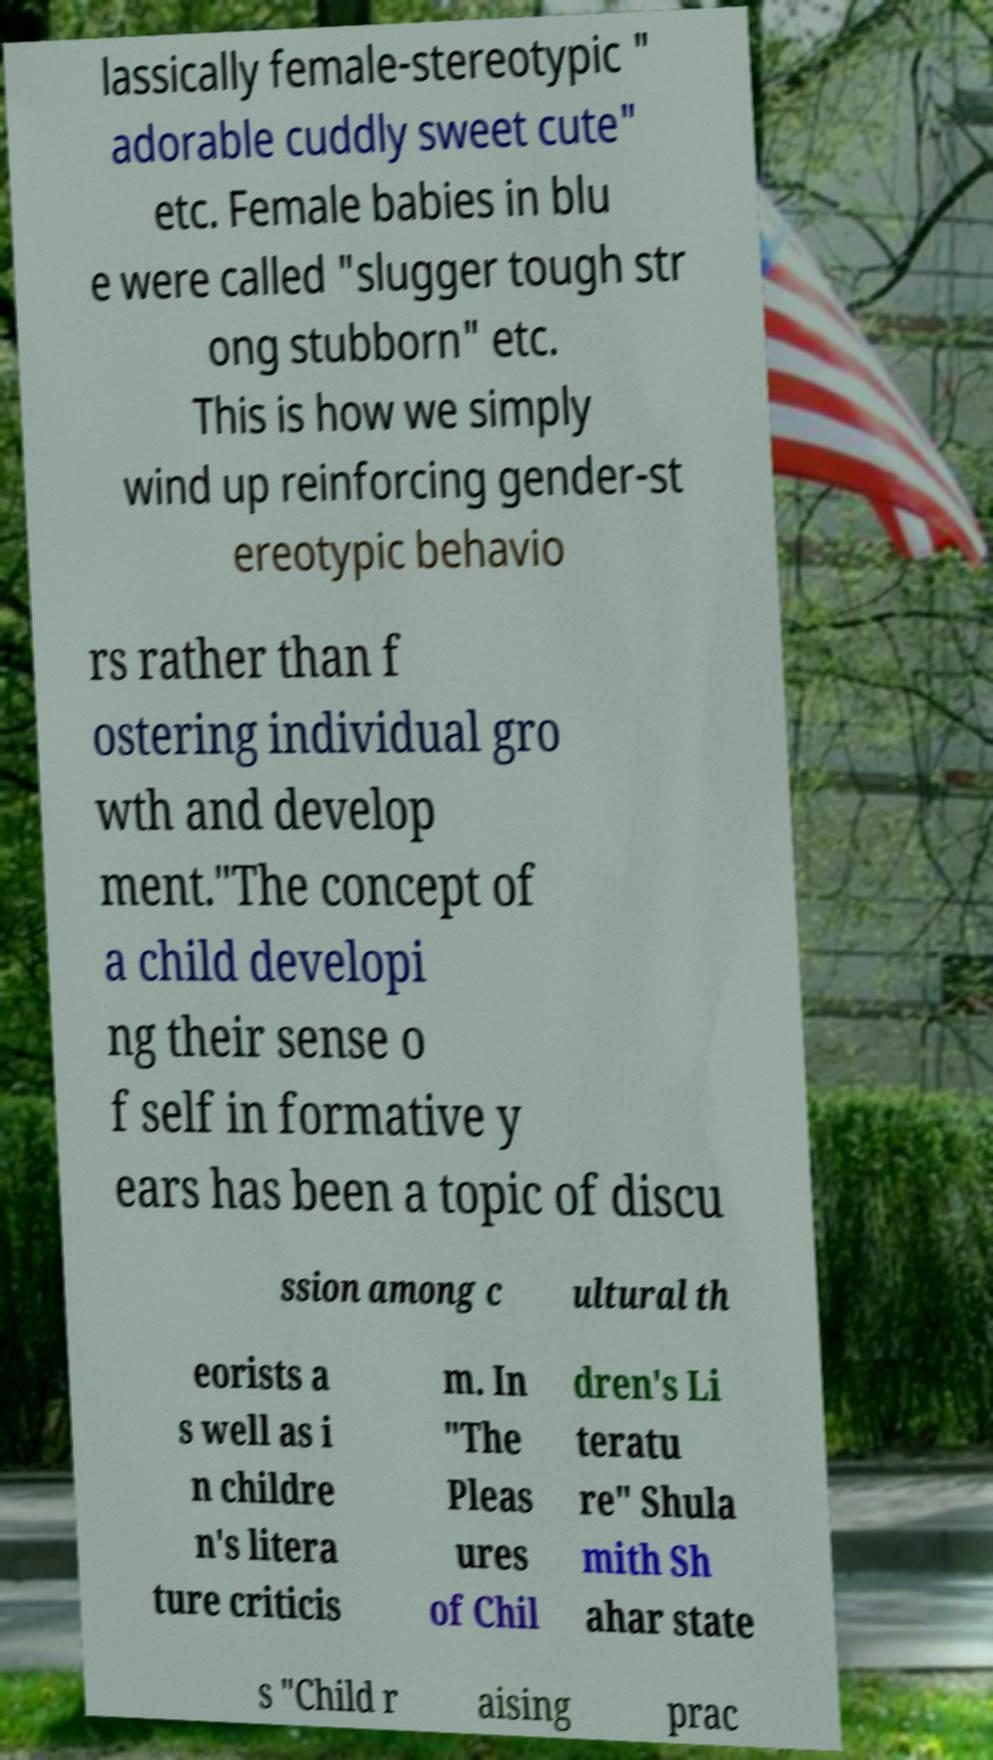For documentation purposes, I need the text within this image transcribed. Could you provide that? lassically female-stereotypic " adorable cuddly sweet cute" etc. Female babies in blu e were called "slugger tough str ong stubborn" etc. This is how we simply wind up reinforcing gender-st ereotypic behavio rs rather than f ostering individual gro wth and develop ment."The concept of a child developi ng their sense o f self in formative y ears has been a topic of discu ssion among c ultural th eorists a s well as i n childre n's litera ture criticis m. In "The Pleas ures of Chil dren's Li teratu re" Shula mith Sh ahar state s "Child r aising prac 